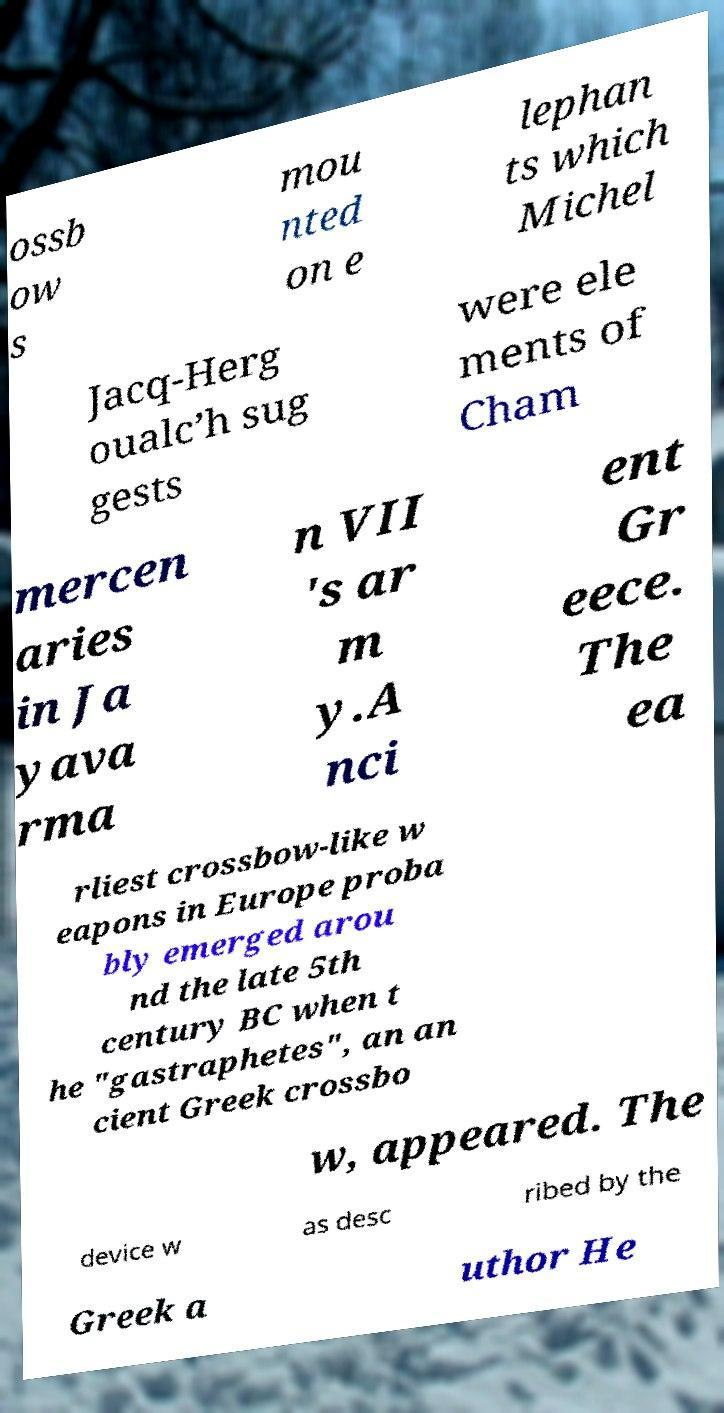Could you assist in decoding the text presented in this image and type it out clearly? ossb ow s mou nted on e lephan ts which Michel Jacq-Herg oualc’h sug gests were ele ments of Cham mercen aries in Ja yava rma n VII 's ar m y.A nci ent Gr eece. The ea rliest crossbow-like w eapons in Europe proba bly emerged arou nd the late 5th century BC when t he "gastraphetes", an an cient Greek crossbo w, appeared. The device w as desc ribed by the Greek a uthor He 